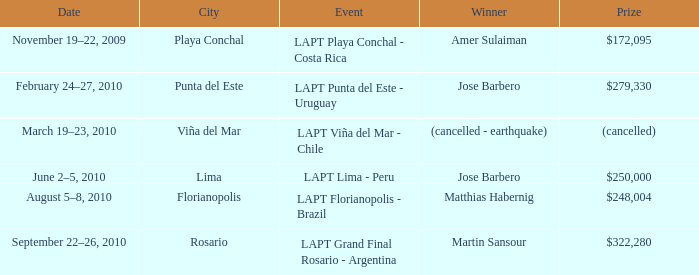Write the full table. {'header': ['Date', 'City', 'Event', 'Winner', 'Prize'], 'rows': [['November 19–22, 2009', 'Playa Conchal', 'LAPT Playa Conchal - Costa Rica', 'Amer Sulaiman', '$172,095'], ['February 24–27, 2010', 'Punta del Este', 'LAPT Punta del Este - Uruguay', 'Jose Barbero', '$279,330'], ['March 19–23, 2010', 'Viña del Mar', 'LAPT Viña del Mar - Chile', '(cancelled - earthquake)', '(cancelled)'], ['June 2–5, 2010', 'Lima', 'LAPT Lima - Peru', 'Jose Barbero', '$250,000'], ['August 5–8, 2010', 'Florianopolis', 'LAPT Florianopolis - Brazil', 'Matthias Habernig', '$248,004'], ['September 22–26, 2010', 'Rosario', 'LAPT Grand Final Rosario - Argentina', 'Martin Sansour', '$322,280']]} Who is the winner in the city of lima? Jose Barbero. 